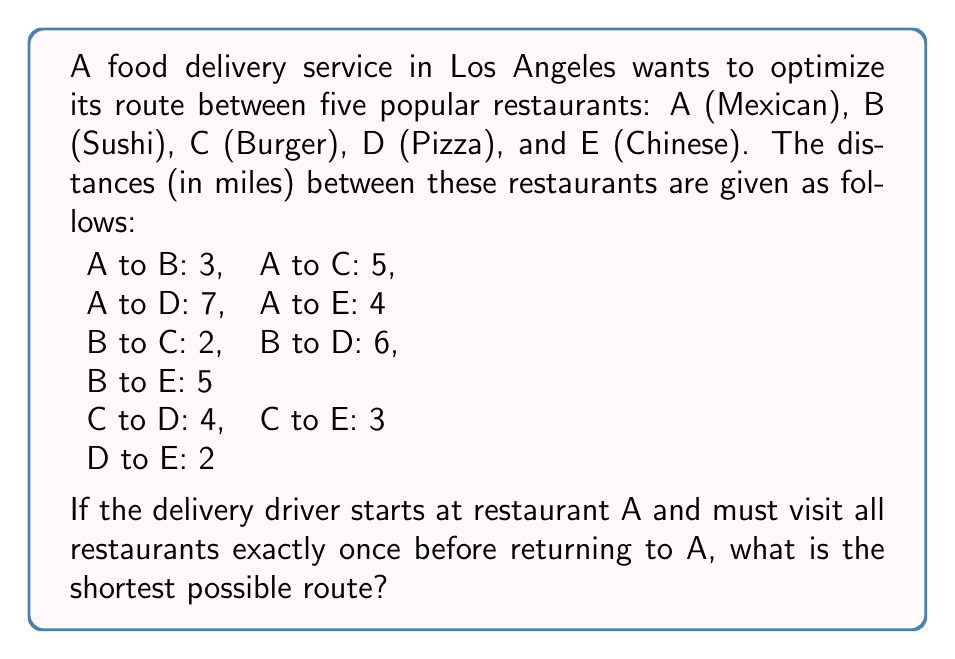Solve this math problem. To solve this problem, we'll use graph theory and the concept of the Traveling Salesman Problem (TSP). Let's approach this step-by-step:

1) First, we'll represent the problem as a complete graph with 5 vertices (A, B, C, D, E) where each edge represents the distance between two restaurants.

2) Since we have a small number of vertices, we can use the brute-force method to find the optimal solution. We'll calculate the total distance for all possible permutations of the restaurants (excluding A as the start and end point).

3) The possible routes are:
   A-B-C-D-E-A
   A-B-C-E-D-A
   A-B-D-C-E-A
   A-B-D-E-C-A
   A-B-E-C-D-A
   A-B-E-D-C-A
   (and 18 more permutations)

4) Let's calculate the distance for each route:
   A-B-C-D-E-A: 3 + 2 + 4 + 2 + 4 = 15
   A-B-C-E-D-A: 3 + 2 + 3 + 2 + 7 = 17
   A-B-D-C-E-A: 3 + 6 + 4 + 3 + 4 = 20
   A-B-D-E-C-A: 3 + 6 + 2 + 3 + 5 = 19
   A-B-E-C-D-A: 3 + 5 + 3 + 4 + 7 = 22
   A-B-E-D-C-A: 3 + 5 + 2 + 4 + 5 = 19

5) After calculating all 24 permutations, we find that the shortest route is A-B-C-D-E-A with a total distance of 15 miles.

This solution can be verified using the following mathematical formulation:

Let $x_{ij}$ be a binary variable that is 1 if the path goes from i to j, and 0 otherwise.
Let $c_{ij}$ be the cost (distance) from i to j.

The objective function to minimize is:

$$\sum_{i=1}^n \sum_{j=1}^n c_{ij}x_{ij}$$

Subject to constraints ensuring each restaurant is visited exactly once and the tour is connected.
Answer: A-B-C-D-E-A, 15 miles 